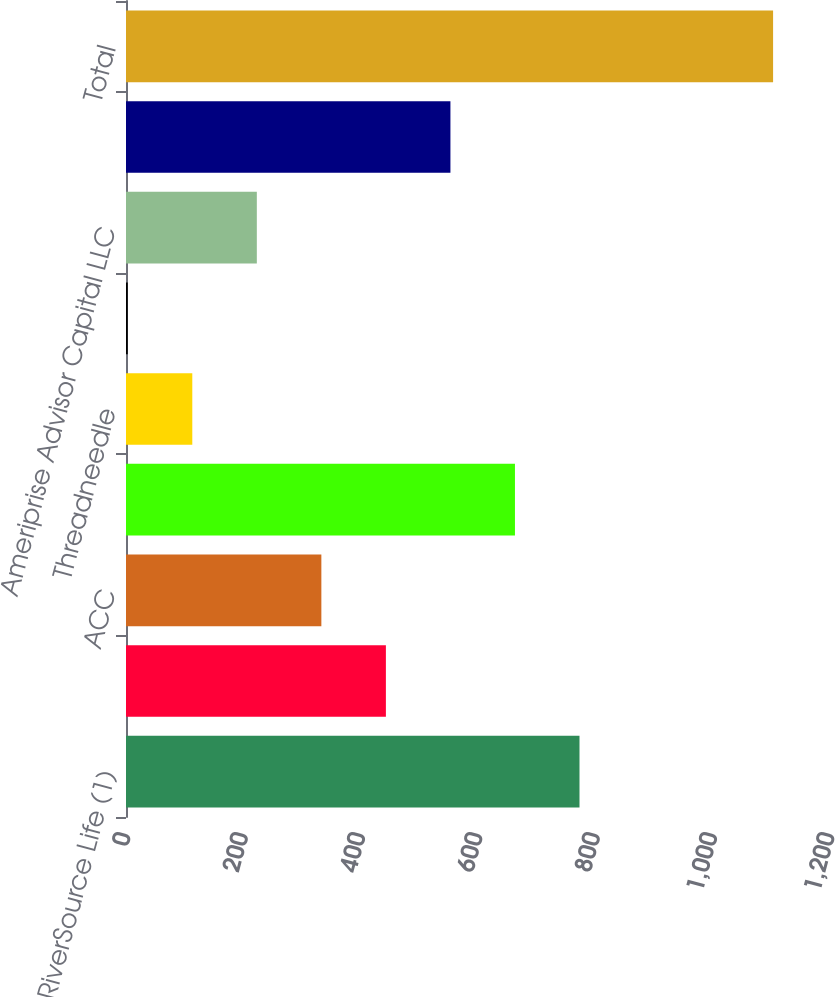Convert chart. <chart><loc_0><loc_0><loc_500><loc_500><bar_chart><fcel>RiverSource Life (1)<fcel>Ameriprise Bank FSB (2)<fcel>ACC<fcel>Columbia Management Investment<fcel>Threadneedle<fcel>Ameriprise Trust Company<fcel>Ameriprise Advisor Capital LLC<fcel>AMPF Holding Corporation<fcel>Total<nl><fcel>773<fcel>443<fcel>333<fcel>663<fcel>113<fcel>3<fcel>223<fcel>553<fcel>1103<nl></chart> 